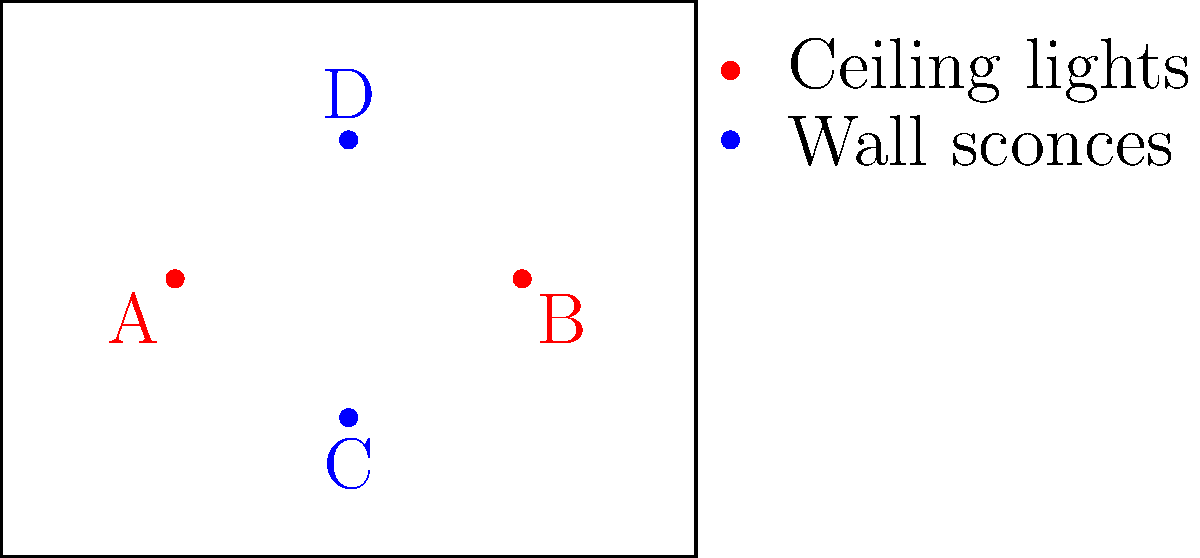As an interior designer, you're tasked with optimizing the lighting design for a rectangular room. The diagram shows four light fixture placements: two ceiling lights (A and B) and two wall sconces (C and D). Which combination of light fixtures would create the most balanced and ambient lighting effect, considering both task lighting and mood enhancement? To determine the most balanced and ambient lighting effect, we need to consider the following factors:

1. Coverage: Ensure that light is distributed evenly throughout the room.
2. Layering: Combine different types of lighting for versatility.
3. Functionality: Provide adequate task lighting for specific areas.
4. Ambiance: Create a mood-enhancing atmosphere.

Step-by-step analysis:

1. Ceiling lights (A and B):
   - Provide general illumination for the entire room.
   - Placed symmetrically, ensuring even coverage.
   - Offer good task lighting for the central area.

2. Wall sconces (C and D):
   - Add ambient lighting and create visual interest.
   - Placed on opposite walls, enhancing depth perception.
   - Contribute to a softer, more relaxing atmosphere.

3. Combining ceiling lights and wall sconces:
   - Creates layered lighting, allowing for flexibility in lighting scenarios.
   - Balances functional task lighting with mood-enhancing ambient light.
   - Allows for control of light intensity and direction.

4. Optimal combination:
   - Using all four fixtures (A, B, C, and D) provides the most balanced and versatile lighting design.
   - Ceiling lights ensure adequate general illumination and task lighting.
   - Wall sconces add depth, ambiance, and visual interest.
   - This combination allows for various lighting scenarios by controlling different fixtures.

Therefore, the most balanced and ambient lighting effect would be achieved by using all four light fixtures in combination.
Answer: All four fixtures (A, B, C, and D) 